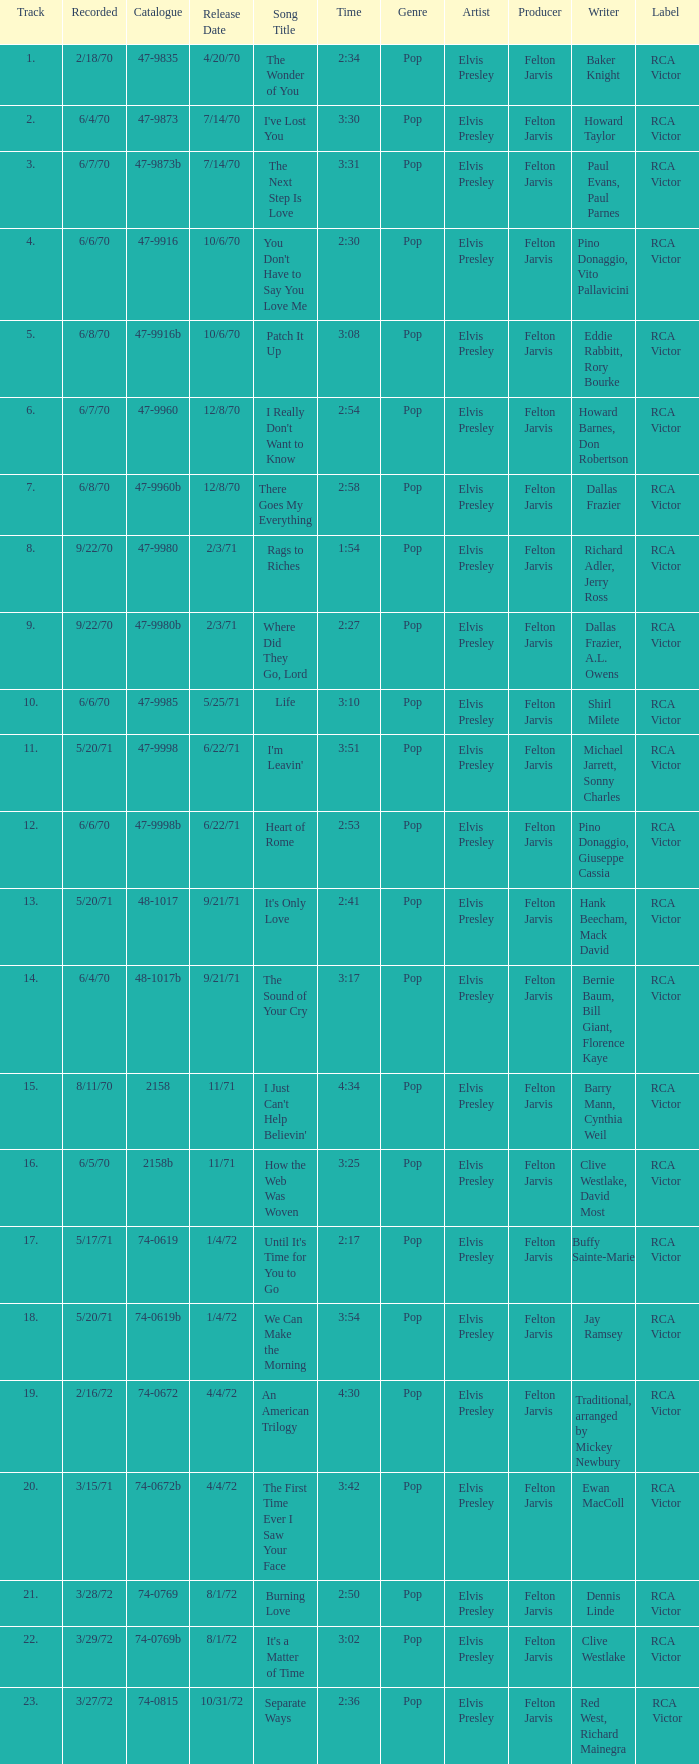Can you provide the catalogue number of heart of rome? 47-9998b. 